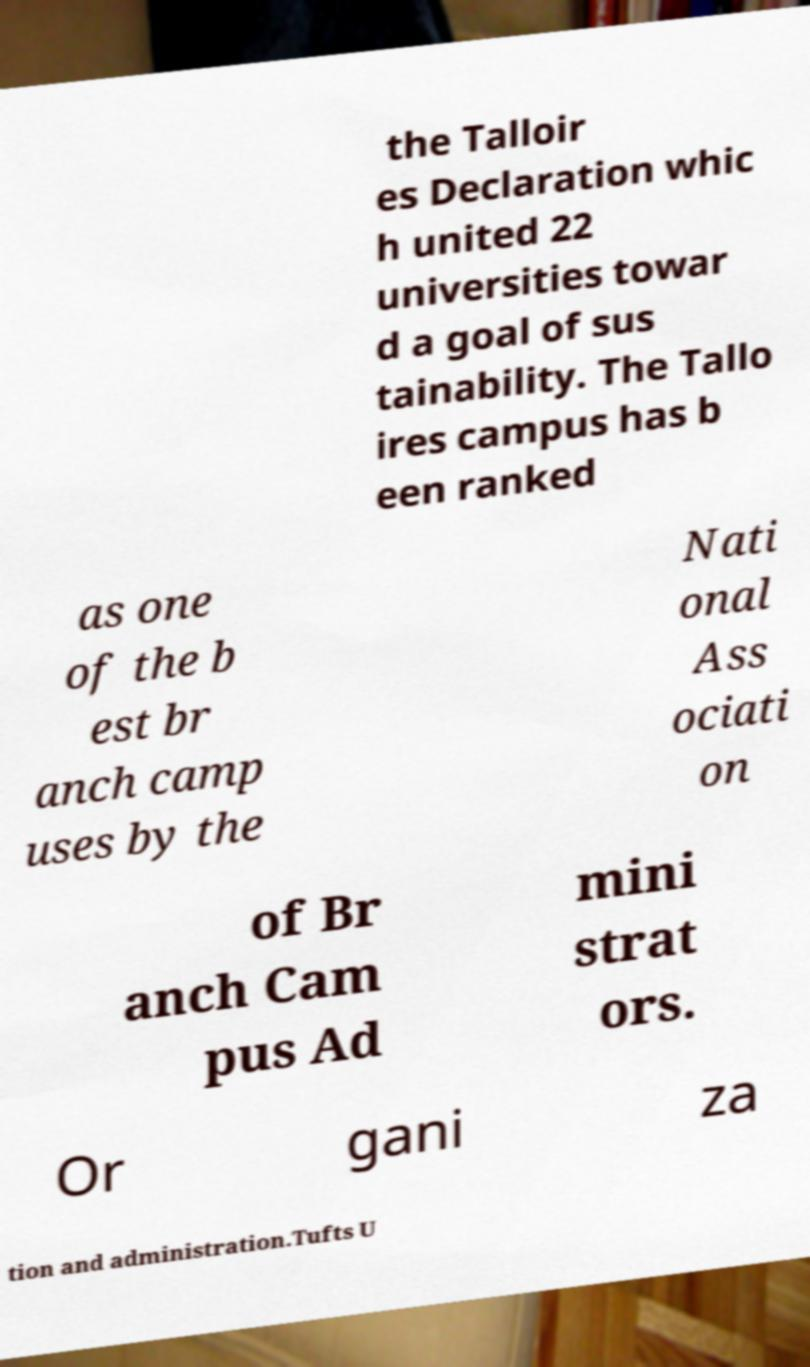Could you extract and type out the text from this image? the Talloir es Declaration whic h united 22 universities towar d a goal of sus tainability. The Tallo ires campus has b een ranked as one of the b est br anch camp uses by the Nati onal Ass ociati on of Br anch Cam pus Ad mini strat ors. Or gani za tion and administration.Tufts U 